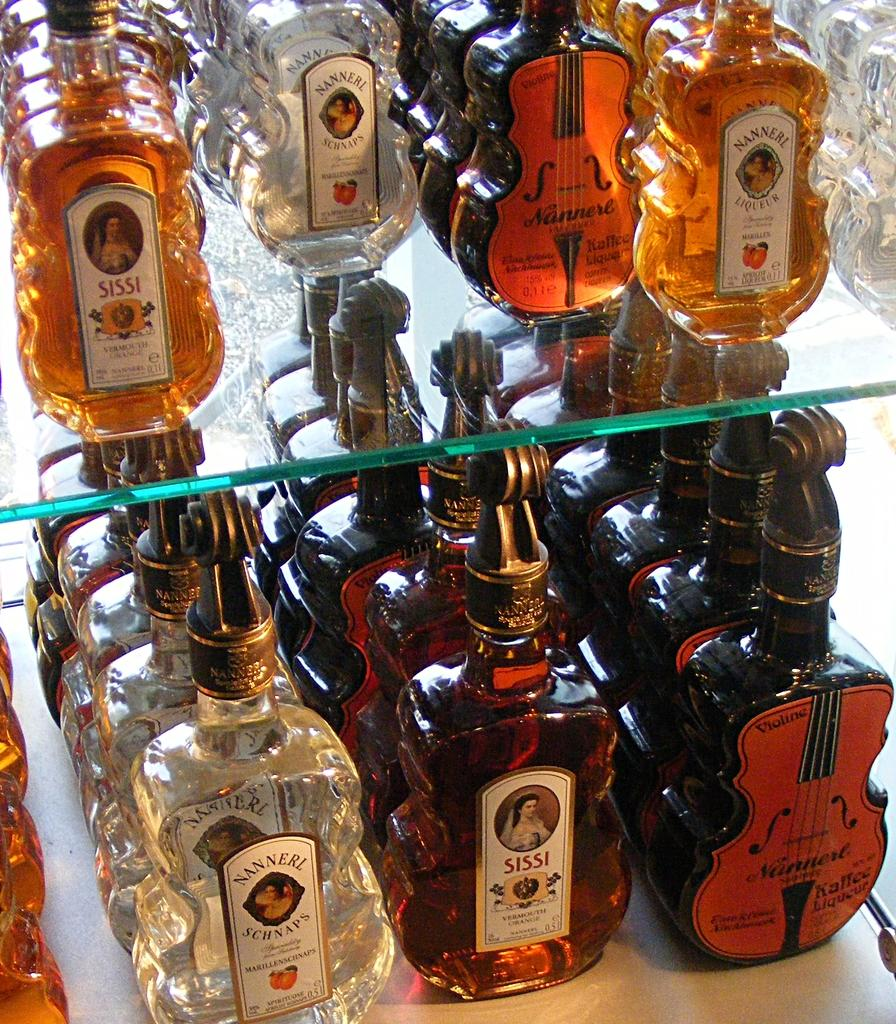Provide a one-sentence caption for the provided image. two shelves of bottles with some labeled as 'nanneri schnaps'. 